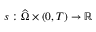<formula> <loc_0><loc_0><loc_500><loc_500>s \colon { \widehat { \Omega } } \times ( 0 , T ) \to \mathbb { R }</formula> 